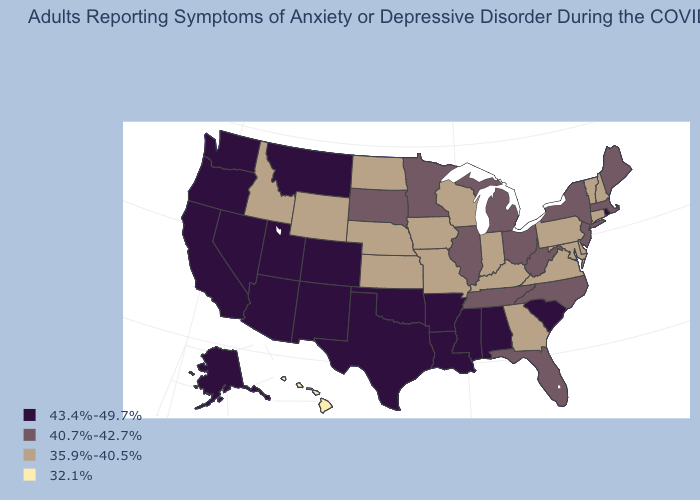Which states hav the highest value in the West?
Keep it brief. Alaska, Arizona, California, Colorado, Montana, Nevada, New Mexico, Oregon, Utah, Washington. Which states have the lowest value in the USA?
Concise answer only. Hawaii. Which states have the lowest value in the West?
Keep it brief. Hawaii. What is the value of New Mexico?
Give a very brief answer. 43.4%-49.7%. What is the value of Hawaii?
Give a very brief answer. 32.1%. What is the lowest value in states that border Maine?
Concise answer only. 35.9%-40.5%. What is the value of New Hampshire?
Concise answer only. 35.9%-40.5%. Name the states that have a value in the range 32.1%?
Write a very short answer. Hawaii. Does Rhode Island have the lowest value in the USA?
Be succinct. No. Does the first symbol in the legend represent the smallest category?
Concise answer only. No. Name the states that have a value in the range 40.7%-42.7%?
Short answer required. Florida, Illinois, Maine, Massachusetts, Michigan, Minnesota, New Jersey, New York, North Carolina, Ohio, South Dakota, Tennessee, West Virginia. How many symbols are there in the legend?
Answer briefly. 4. What is the highest value in the USA?
Write a very short answer. 43.4%-49.7%. Does West Virginia have the same value as Arkansas?
Answer briefly. No. Name the states that have a value in the range 40.7%-42.7%?
Quick response, please. Florida, Illinois, Maine, Massachusetts, Michigan, Minnesota, New Jersey, New York, North Carolina, Ohio, South Dakota, Tennessee, West Virginia. 